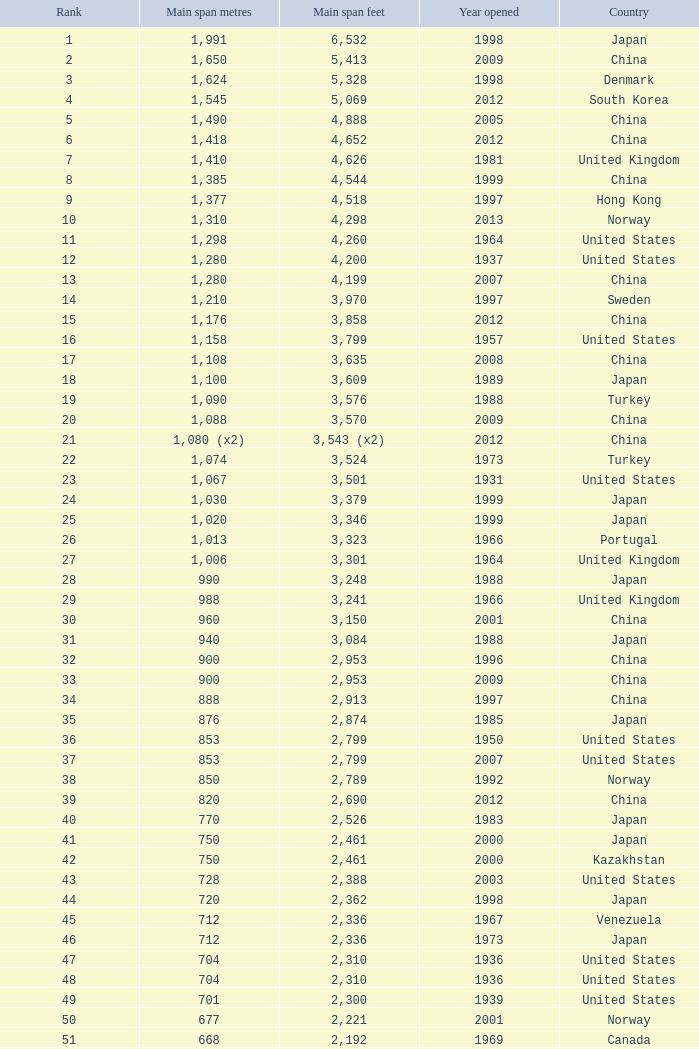From 1936, what is the primary span in feet for a bridge in the united states with a ranking higher than 47 and a main span of 421 meters? 1381.0. 